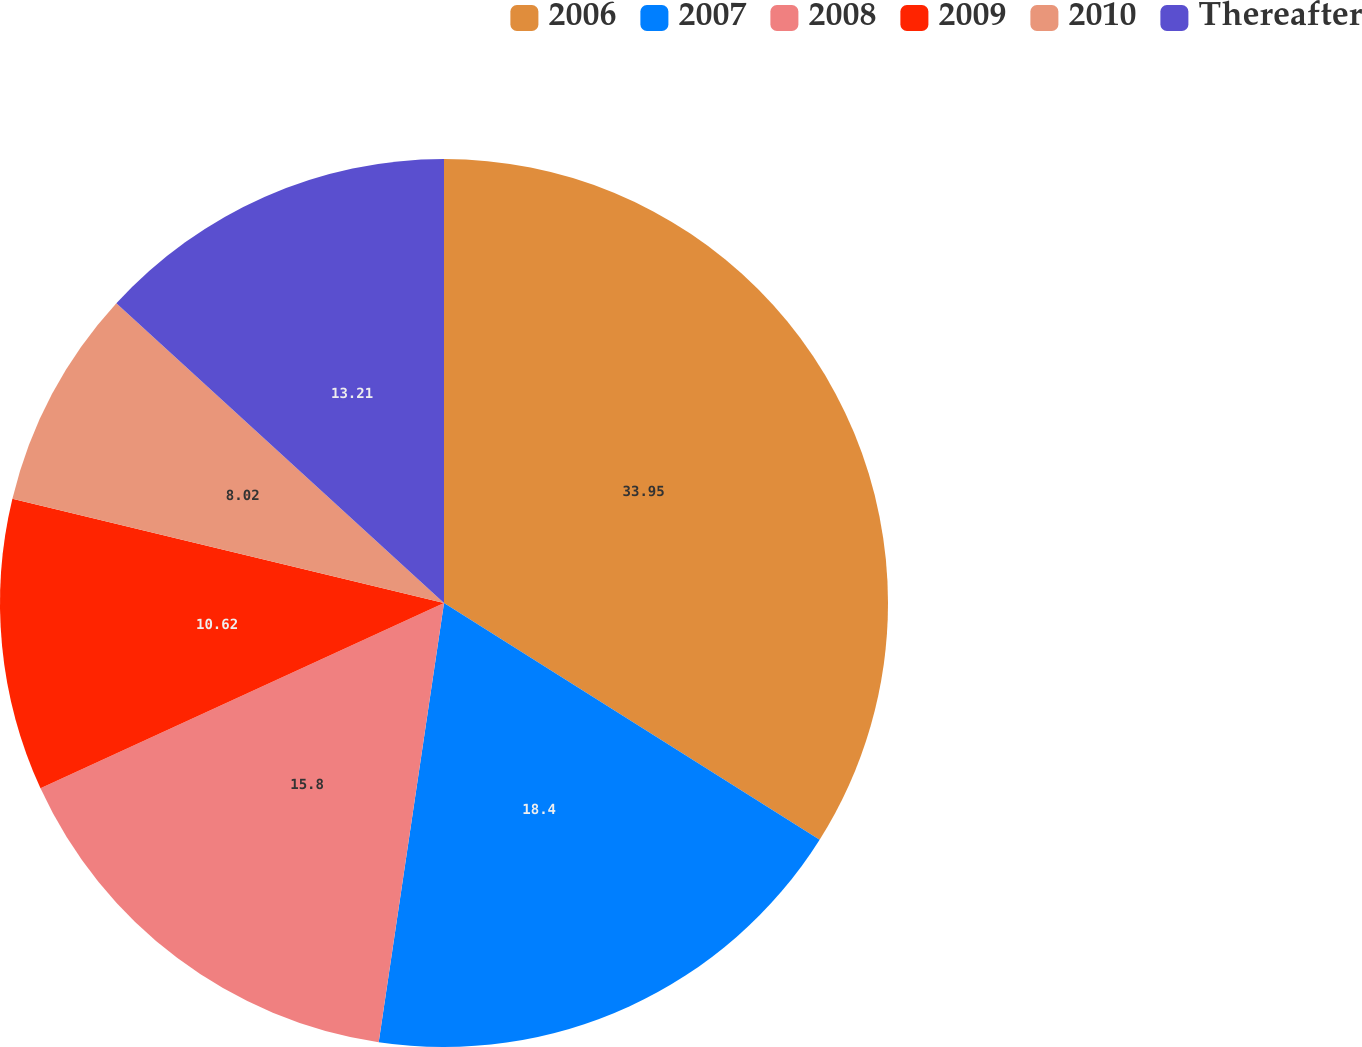Convert chart to OTSL. <chart><loc_0><loc_0><loc_500><loc_500><pie_chart><fcel>2006<fcel>2007<fcel>2008<fcel>2009<fcel>2010<fcel>Thereafter<nl><fcel>33.95%<fcel>18.4%<fcel>15.8%<fcel>10.62%<fcel>8.02%<fcel>13.21%<nl></chart> 